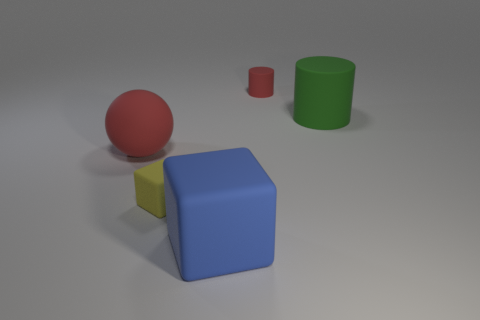Add 1 red matte objects. How many objects exist? 6 Subtract all cubes. How many objects are left? 3 Subtract 0 yellow cylinders. How many objects are left? 5 Subtract all large cylinders. Subtract all tiny yellow rubber cubes. How many objects are left? 3 Add 2 big red matte spheres. How many big red matte spheres are left? 3 Add 2 red cylinders. How many red cylinders exist? 3 